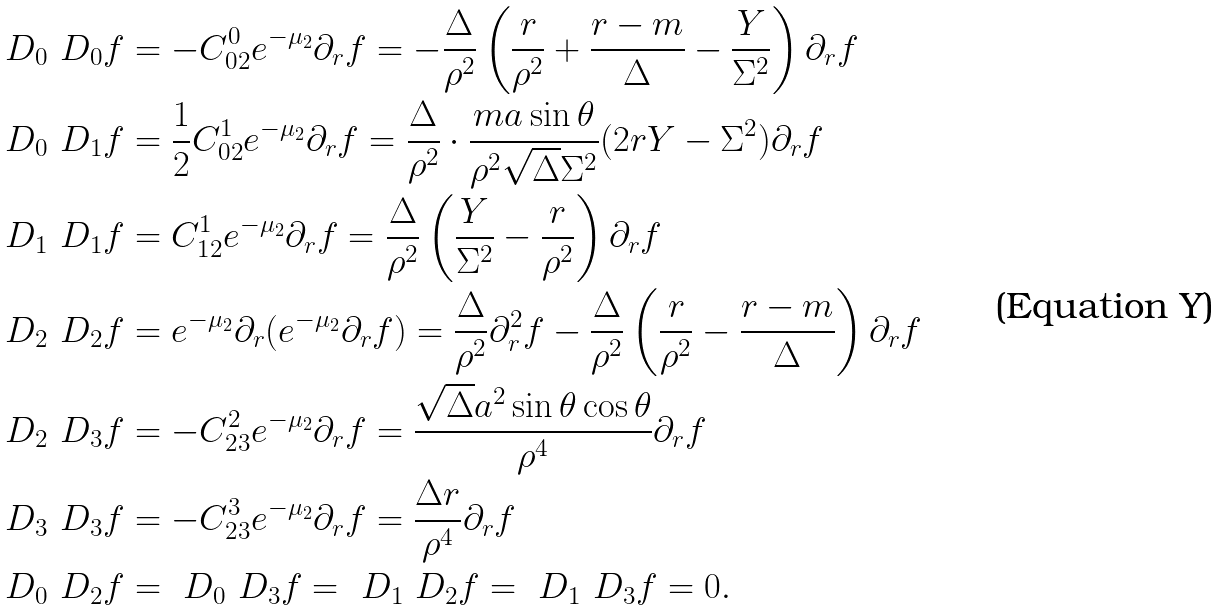Convert formula to latex. <formula><loc_0><loc_0><loc_500><loc_500>& \ D _ { 0 } \ D _ { 0 } f = - C _ { 0 2 } ^ { 0 } e ^ { - \mu _ { 2 } } \partial _ { r } f = - \frac { \Delta } { \rho ^ { 2 } } \left ( \frac { r } { \rho ^ { 2 } } + \frac { r - m } { \Delta } - \frac { Y } { \Sigma ^ { 2 } } \right ) \partial _ { r } f \\ & \ D _ { 0 } \ D _ { 1 } f = \frac { 1 } { 2 } C _ { 0 2 } ^ { 1 } e ^ { - \mu _ { 2 } } \partial _ { r } f = \frac { \Delta } { \rho ^ { 2 } } \cdot \frac { m a \sin \theta } { \rho ^ { 2 } \sqrt { \Delta } \Sigma ^ { 2 } } ( 2 r Y - \Sigma ^ { 2 } ) \partial _ { r } f \\ & \ D _ { 1 } \ D _ { 1 } f = C _ { 1 2 } ^ { 1 } e ^ { - \mu _ { 2 } } \partial _ { r } f = \frac { \Delta } { \rho ^ { 2 } } \left ( \frac { Y } { \Sigma ^ { 2 } } - \frac { r } { \rho ^ { 2 } } \right ) \partial _ { r } f \\ & \ D _ { 2 } \ D _ { 2 } f = e ^ { - \mu _ { 2 } } \partial _ { r } ( e ^ { - \mu _ { 2 } } \partial _ { r } f ) = \frac { \Delta } { \rho ^ { 2 } } \partial ^ { 2 } _ { r } f - \frac { \Delta } { \rho ^ { 2 } } \left ( \frac { r } { \rho ^ { 2 } } - \frac { r - m } { \Delta } \right ) \partial _ { r } f \\ & \ D _ { 2 } \ D _ { 3 } f = - C _ { 2 3 } ^ { 2 } e ^ { - \mu _ { 2 } } \partial _ { r } f = \frac { \sqrt { \Delta } a ^ { 2 } \sin \theta \cos \theta } { \rho ^ { 4 } } \partial _ { r } f \\ & \ D _ { 3 } \ D _ { 3 } f = - C _ { 2 3 } ^ { 3 } e ^ { - \mu _ { 2 } } \partial _ { r } f = \frac { \Delta r } { \rho ^ { 4 } } \partial _ { r } f \\ & \ D _ { 0 } \ D _ { 2 } f = \ D _ { 0 } \ D _ { 3 } f = \ D _ { 1 } \ D _ { 2 } f = \ D _ { 1 } \ D _ { 3 } f = 0 .</formula> 